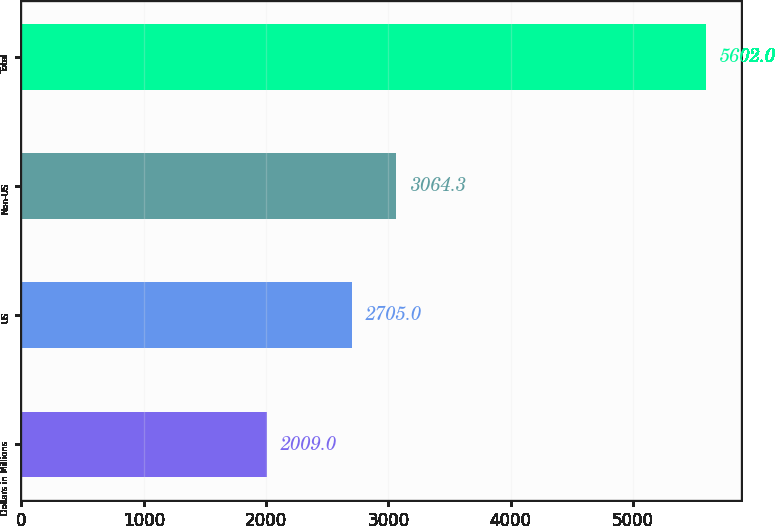<chart> <loc_0><loc_0><loc_500><loc_500><bar_chart><fcel>Dollars in Millions<fcel>US<fcel>Non-US<fcel>Total<nl><fcel>2009<fcel>2705<fcel>3064.3<fcel>5602<nl></chart> 